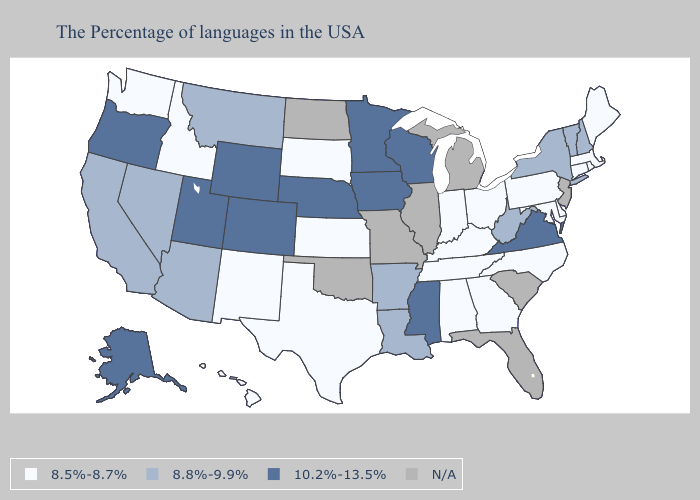Name the states that have a value in the range 10.2%-13.5%?
Keep it brief. Virginia, Wisconsin, Mississippi, Minnesota, Iowa, Nebraska, Wyoming, Colorado, Utah, Oregon, Alaska. Among the states that border Tennessee , which have the lowest value?
Answer briefly. North Carolina, Georgia, Kentucky, Alabama. Does Indiana have the lowest value in the MidWest?
Write a very short answer. Yes. What is the value of Florida?
Keep it brief. N/A. Among the states that border Kentucky , does Ohio have the lowest value?
Give a very brief answer. Yes. Does Oregon have the highest value in the USA?
Write a very short answer. Yes. What is the value of New Mexico?
Keep it brief. 8.5%-8.7%. Does the first symbol in the legend represent the smallest category?
Short answer required. Yes. Is the legend a continuous bar?
Short answer required. No. Does the map have missing data?
Concise answer only. Yes. Which states have the lowest value in the South?
Quick response, please. Delaware, Maryland, North Carolina, Georgia, Kentucky, Alabama, Tennessee, Texas. Does Vermont have the lowest value in the Northeast?
Give a very brief answer. No. What is the value of Oklahoma?
Keep it brief. N/A. What is the highest value in states that border Maryland?
Keep it brief. 10.2%-13.5%. 